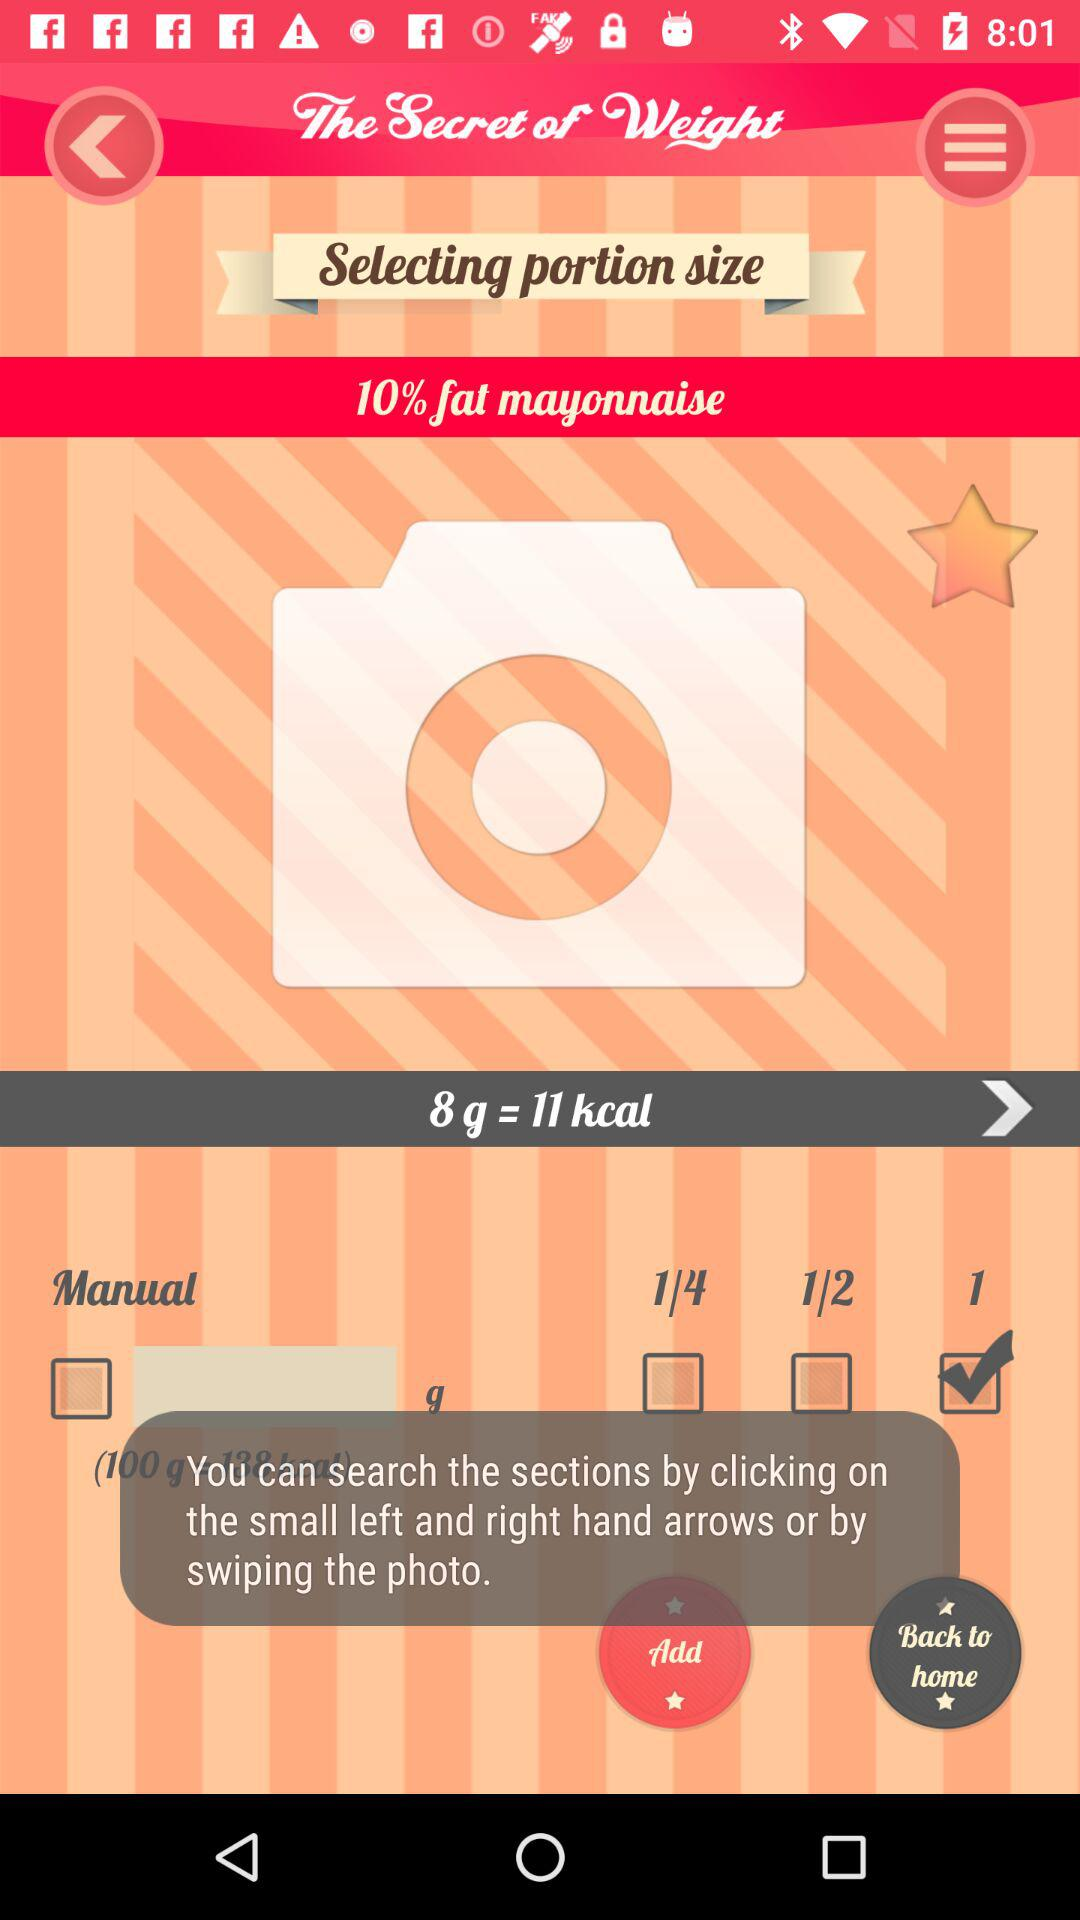Which option is checked? The checked option is "1". 